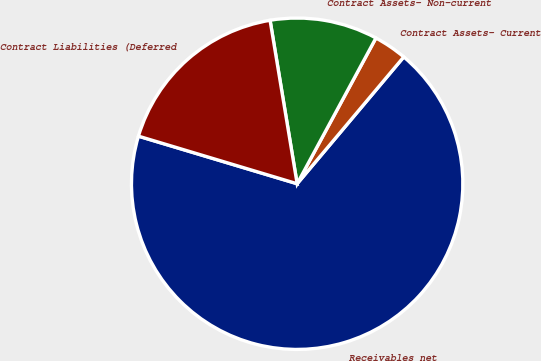Convert chart. <chart><loc_0><loc_0><loc_500><loc_500><pie_chart><fcel>Receivables net<fcel>Contract Assets- Current<fcel>Contract Assets- Non-current<fcel>Contract Liabilities (Deferred<nl><fcel>68.51%<fcel>3.24%<fcel>10.5%<fcel>17.75%<nl></chart> 